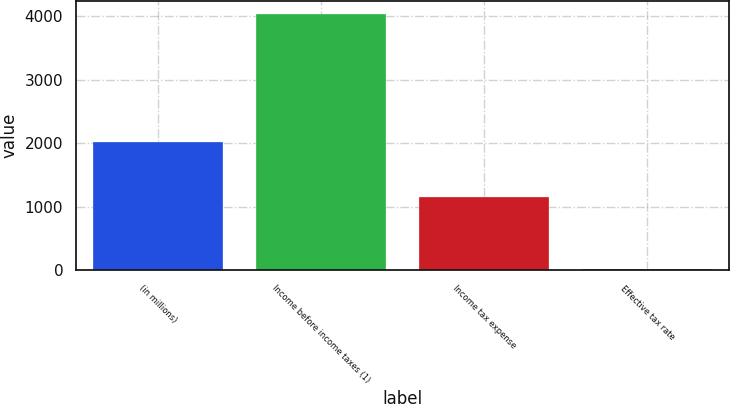<chart> <loc_0><loc_0><loc_500><loc_500><bar_chart><fcel>(in millions)<fcel>Income before income taxes (1)<fcel>Income tax expense<fcel>Effective tax rate<nl><fcel>2013<fcel>4031<fcel>1149<fcel>28.5<nl></chart> 